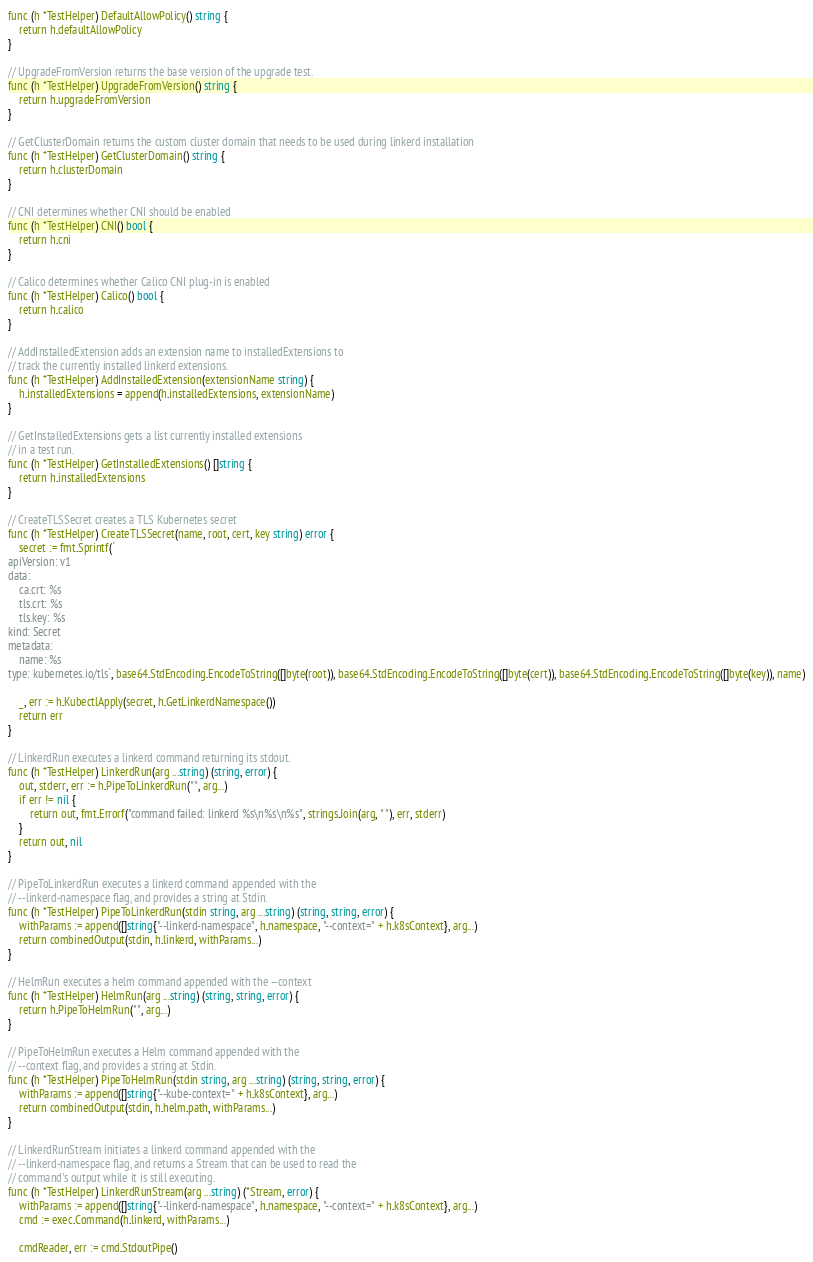<code> <loc_0><loc_0><loc_500><loc_500><_Go_>func (h *TestHelper) DefaultAllowPolicy() string {
	return h.defaultAllowPolicy
}

// UpgradeFromVersion returns the base version of the upgrade test.
func (h *TestHelper) UpgradeFromVersion() string {
	return h.upgradeFromVersion
}

// GetClusterDomain returns the custom cluster domain that needs to be used during linkerd installation
func (h *TestHelper) GetClusterDomain() string {
	return h.clusterDomain
}

// CNI determines whether CNI should be enabled
func (h *TestHelper) CNI() bool {
	return h.cni
}

// Calico determines whether Calico CNI plug-in is enabled
func (h *TestHelper) Calico() bool {
	return h.calico
}

// AddInstalledExtension adds an extension name to installedExtensions to
// track the currently installed linkerd extensions.
func (h *TestHelper) AddInstalledExtension(extensionName string) {
	h.installedExtensions = append(h.installedExtensions, extensionName)
}

// GetInstalledExtensions gets a list currently installed extensions
// in a test run.
func (h *TestHelper) GetInstalledExtensions() []string {
	return h.installedExtensions
}

// CreateTLSSecret creates a TLS Kubernetes secret
func (h *TestHelper) CreateTLSSecret(name, root, cert, key string) error {
	secret := fmt.Sprintf(`
apiVersion: v1
data:
    ca.crt: %s
    tls.crt: %s
    tls.key: %s
kind: Secret
metadata:
    name: %s
type: kubernetes.io/tls`, base64.StdEncoding.EncodeToString([]byte(root)), base64.StdEncoding.EncodeToString([]byte(cert)), base64.StdEncoding.EncodeToString([]byte(key)), name)

	_, err := h.KubectlApply(secret, h.GetLinkerdNamespace())
	return err
}

// LinkerdRun executes a linkerd command returning its stdout.
func (h *TestHelper) LinkerdRun(arg ...string) (string, error) {
	out, stderr, err := h.PipeToLinkerdRun("", arg...)
	if err != nil {
		return out, fmt.Errorf("command failed: linkerd %s\n%s\n%s", strings.Join(arg, " "), err, stderr)
	}
	return out, nil
}

// PipeToLinkerdRun executes a linkerd command appended with the
// --linkerd-namespace flag, and provides a string at Stdin.
func (h *TestHelper) PipeToLinkerdRun(stdin string, arg ...string) (string, string, error) {
	withParams := append([]string{"--linkerd-namespace", h.namespace, "--context=" + h.k8sContext}, arg...)
	return combinedOutput(stdin, h.linkerd, withParams...)
}

// HelmRun executes a helm command appended with the --context
func (h *TestHelper) HelmRun(arg ...string) (string, string, error) {
	return h.PipeToHelmRun("", arg...)
}

// PipeToHelmRun executes a Helm command appended with the
// --context flag, and provides a string at Stdin.
func (h *TestHelper) PipeToHelmRun(stdin string, arg ...string) (string, string, error) {
	withParams := append([]string{"--kube-context=" + h.k8sContext}, arg...)
	return combinedOutput(stdin, h.helm.path, withParams...)
}

// LinkerdRunStream initiates a linkerd command appended with the
// --linkerd-namespace flag, and returns a Stream that can be used to read the
// command's output while it is still executing.
func (h *TestHelper) LinkerdRunStream(arg ...string) (*Stream, error) {
	withParams := append([]string{"--linkerd-namespace", h.namespace, "--context=" + h.k8sContext}, arg...)
	cmd := exec.Command(h.linkerd, withParams...)

	cmdReader, err := cmd.StdoutPipe()</code> 